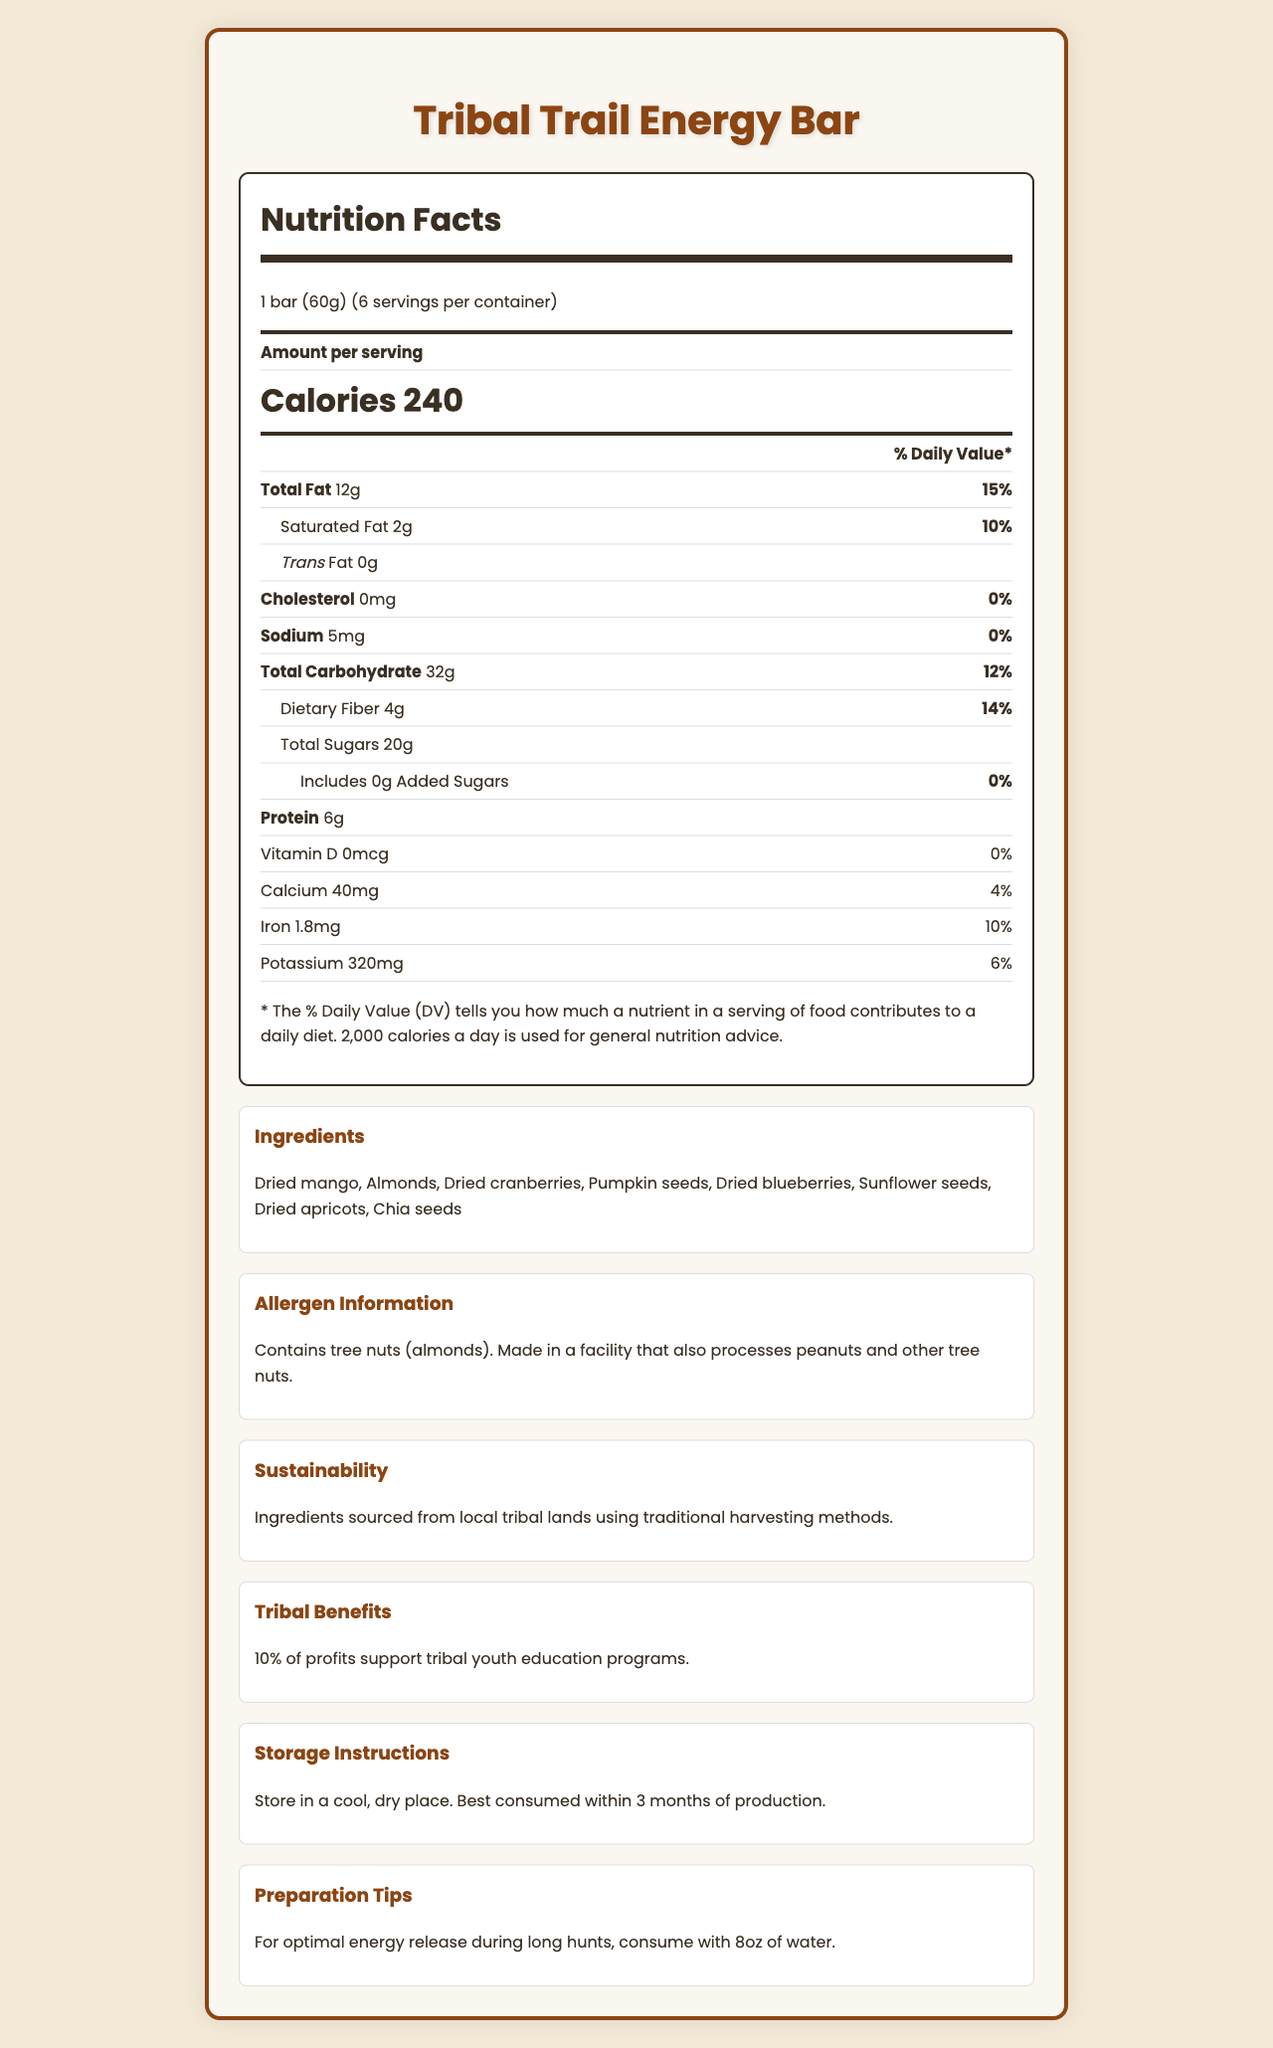what is the serving size of the Tribal Trail Energy Bar? The serving size is listed at the top of the Nutrition Facts panel as "1 bar (60g)".
Answer: 1 bar (60g) how many calories are there per serving? The amount of calories per serving is clearly indicated in the Nutrition Facts panel as "Calories 240".
Answer: 240 what percentage of the daily value is the total fat content? The percentage daily value for total fat is listed as "15%" next to "Total Fat" in the Nutrition Facts panel.
Answer: 15% how much dietary fiber does one bar contain? The amount of dietary fiber per serving is listed as "Dietary Fiber 4g" in the Nutrition Facts panel.
Answer: 4g what is the amount of protein in each bar? The protein content is listed in the Nutrition Facts panel as "Protein 6g".
Answer: 6g which of the following ingredients are included in the Tribal Trail Energy Bar? A. Cashews B. Almonds C. Raisins The list of ingredients includes "Almonds" but neither "Cashews" nor "Raisins".
Answer: B. Almonds how much calcium does one serving provide? A. 20mg B. 40mg C. 60mg D. 80mg The calcium amount per serving is listed as "Calcium 40mg" in the Nutrition Facts panel.
Answer: B. 40mg can people with peanut allergies consume this product without any caution? The Allergen Information section states that it "Contains tree nuts (almonds)" and is "Made in a facility that also processes peanuts and other tree nuts".
Answer: No does this product contain any added sugars? The Nutrition Facts panel lists "Includes 0g Added Sugars" indicating there are no added sugars.
Answer: No describe the sustainability efforts related to this energy bar. The Sustainability section indicates that the ingredients are sourced from local tribal lands using traditional harvesting methods.
Answer: Ingredients sourced from local tribal lands using traditional harvesting methods. how many bars are there in one container? The document mentions that the serving size is 1 bar (60g) and there are 6 servings per container, meaning 6 bars per container.
Answer: 6 how much iron is there in one energy bar? The iron content per serving is listed as "Iron 1.8mg" in the Nutrition Facts panel.
Answer: 1.8mg how should you store the Tribal Trail Energy Bar? The storage instructions specify to store the bars in a cool, dry place and state that they are best consumed within 3 months of production.
Answer: Store in a cool, dry place. Best consumed within 3 months of production. how does this product benefit tribal communities? The Tribal Benefits section states that 10% of profits go towards supporting tribal youth education programs.
Answer: 10% of profits support tribal youth education programs. what is the container size of this product in grams? The document provides serving size and servings per container but does not explicitly state the total container weight in grams.
Answer: Not enough information what is the main purpose of consuming the Tribal Trail Energy Bar with 8oz of water during long hunts? The preparation tips section advises consuming the bar with 8oz of water during long hunts for optimal energy release.
Answer: For optimal energy release. what are the main components of the document? The document contains multiple sections: Nutrition Facts, Ingredients, Allergen Information, Sustainability Information, Tribal Benefits, Storage Instructions, and Preparation Tips. Each section details different aspects related to the Tribal Trail Energy Bar.
Answer: The document includes a detailed Nutrition Facts Label for the Tribal Trail Energy Bar, listing nutritional contents per serving, ingredients, allergen information, sustainability efforts, tribal benefits, storage instructions, and preparation tips. 